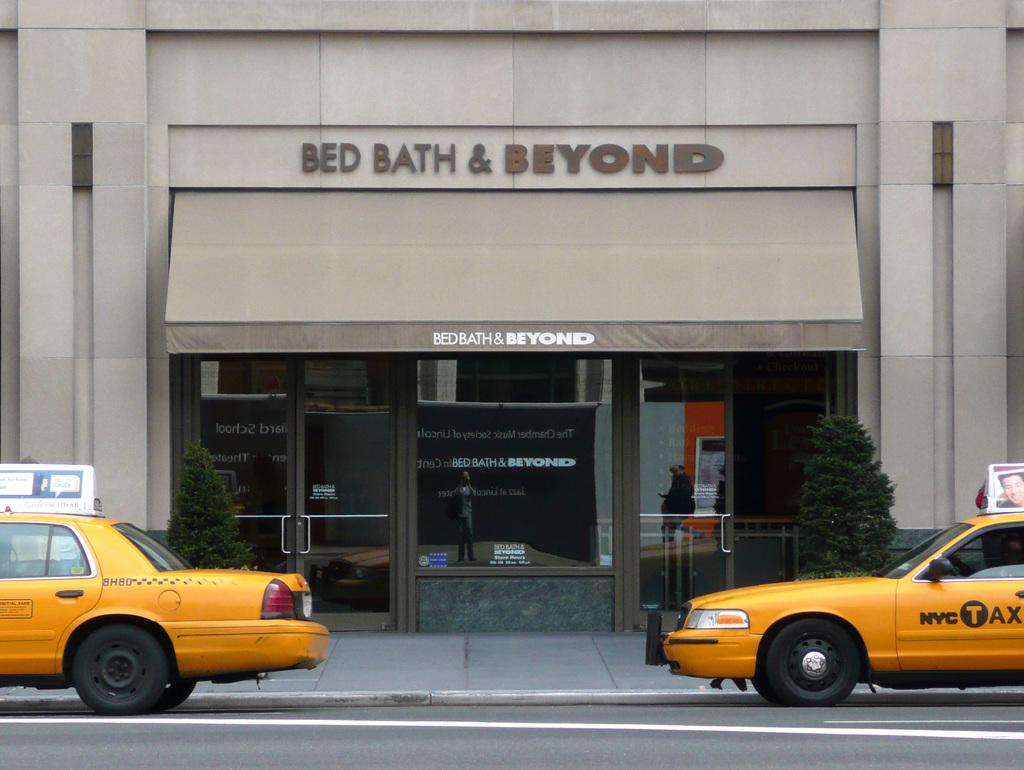What is the main structure in the image? There is a building in the center of the image. What can be seen on the ground in the image? Cars are visible on the road at the bottom of the image. Are there any plants or vegetation in the image? Yes, there are bushes in the image. What type of ink can be seen on the squirrel in the image? There is no squirrel present in the image, and therefore no ink can be seen on it. 